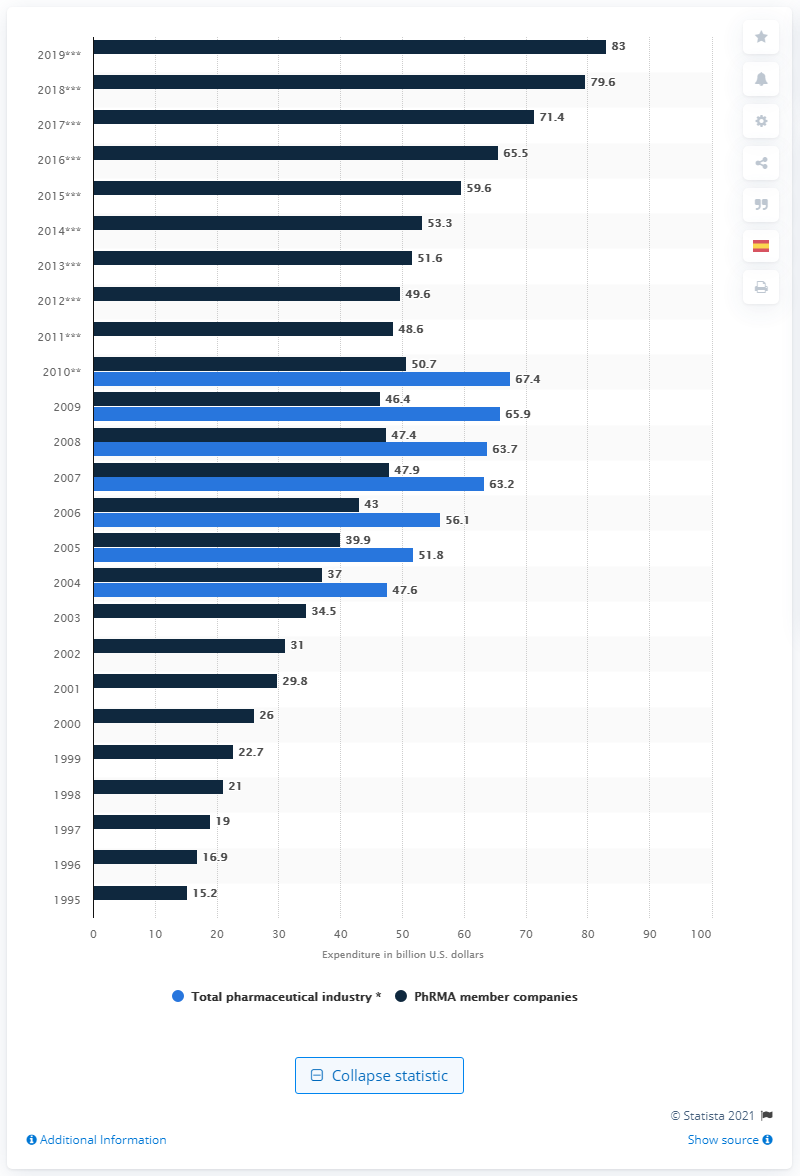Give some essential details in this illustration. According to PhRMA member companies, their R&D expenditure in 2019 was approximately 83... 